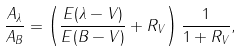Convert formula to latex. <formula><loc_0><loc_0><loc_500><loc_500>\frac { A _ { \lambda } } { A _ { B } } = \left ( \frac { E ( \lambda - V ) } { E ( B - V ) } + R _ { V } \right ) \frac { 1 } { 1 + R _ { V } } ,</formula> 